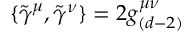<formula> <loc_0><loc_0><loc_500><loc_500>\{ \tilde { \gamma } ^ { \mu } , \tilde { \gamma } ^ { \nu } \} = 2 g _ { ( d - 2 ) } ^ { \mu \nu }</formula> 